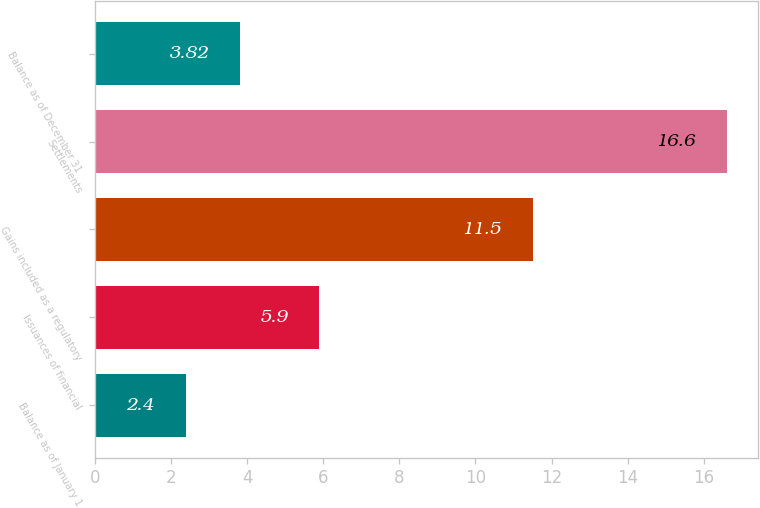Convert chart. <chart><loc_0><loc_0><loc_500><loc_500><bar_chart><fcel>Balance as of January 1<fcel>Issuances of financial<fcel>Gains included as a regulatory<fcel>Settlements<fcel>Balance as of December 31<nl><fcel>2.4<fcel>5.9<fcel>11.5<fcel>16.6<fcel>3.82<nl></chart> 